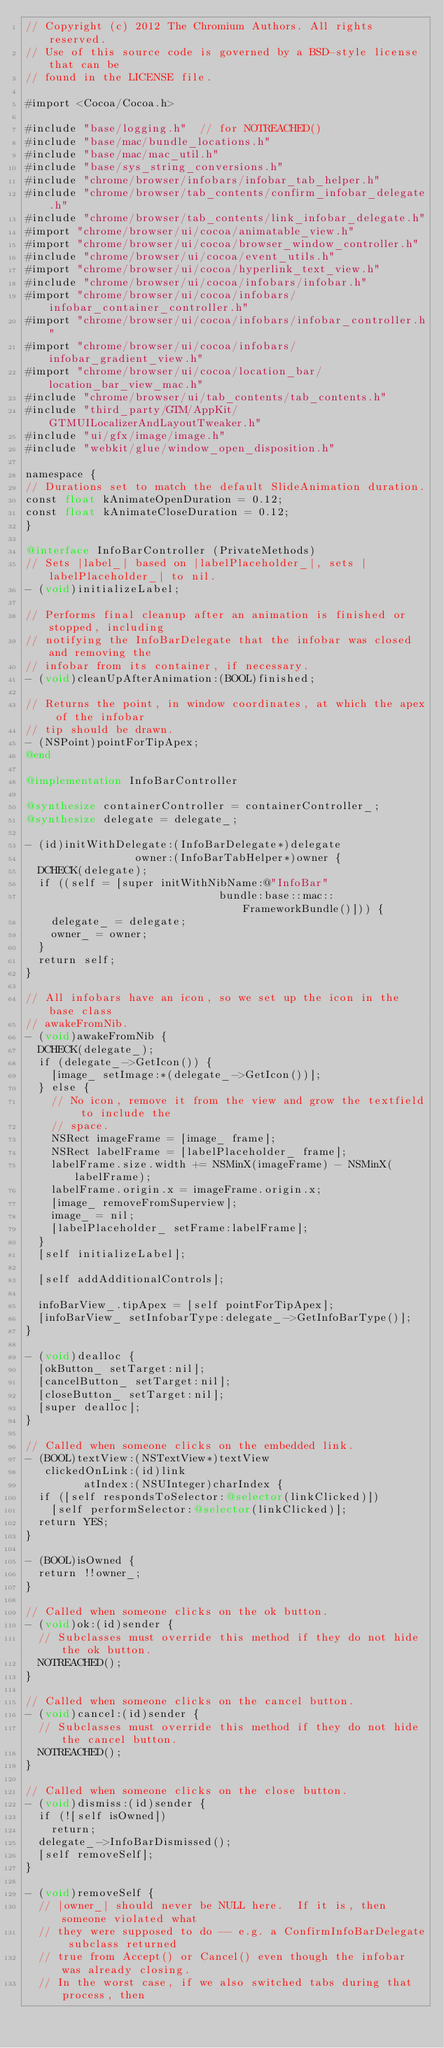<code> <loc_0><loc_0><loc_500><loc_500><_ObjectiveC_>// Copyright (c) 2012 The Chromium Authors. All rights reserved.
// Use of this source code is governed by a BSD-style license that can be
// found in the LICENSE file.

#import <Cocoa/Cocoa.h>

#include "base/logging.h"  // for NOTREACHED()
#include "base/mac/bundle_locations.h"
#include "base/mac/mac_util.h"
#include "base/sys_string_conversions.h"
#include "chrome/browser/infobars/infobar_tab_helper.h"
#include "chrome/browser/tab_contents/confirm_infobar_delegate.h"
#include "chrome/browser/tab_contents/link_infobar_delegate.h"
#import "chrome/browser/ui/cocoa/animatable_view.h"
#import "chrome/browser/ui/cocoa/browser_window_controller.h"
#include "chrome/browser/ui/cocoa/event_utils.h"
#import "chrome/browser/ui/cocoa/hyperlink_text_view.h"
#include "chrome/browser/ui/cocoa/infobars/infobar.h"
#import "chrome/browser/ui/cocoa/infobars/infobar_container_controller.h"
#import "chrome/browser/ui/cocoa/infobars/infobar_controller.h"
#import "chrome/browser/ui/cocoa/infobars/infobar_gradient_view.h"
#import "chrome/browser/ui/cocoa/location_bar/location_bar_view_mac.h"
#include "chrome/browser/ui/tab_contents/tab_contents.h"
#include "third_party/GTM/AppKit/GTMUILocalizerAndLayoutTweaker.h"
#include "ui/gfx/image/image.h"
#include "webkit/glue/window_open_disposition.h"

namespace {
// Durations set to match the default SlideAnimation duration.
const float kAnimateOpenDuration = 0.12;
const float kAnimateCloseDuration = 0.12;
}

@interface InfoBarController (PrivateMethods)
// Sets |label_| based on |labelPlaceholder_|, sets |labelPlaceholder_| to nil.
- (void)initializeLabel;

// Performs final cleanup after an animation is finished or stopped, including
// notifying the InfoBarDelegate that the infobar was closed and removing the
// infobar from its container, if necessary.
- (void)cleanUpAfterAnimation:(BOOL)finished;

// Returns the point, in window coordinates, at which the apex of the infobar
// tip should be drawn.
- (NSPoint)pointForTipApex;
@end

@implementation InfoBarController

@synthesize containerController = containerController_;
@synthesize delegate = delegate_;

- (id)initWithDelegate:(InfoBarDelegate*)delegate
                 owner:(InfoBarTabHelper*)owner {
  DCHECK(delegate);
  if ((self = [super initWithNibName:@"InfoBar"
                              bundle:base::mac::FrameworkBundle()])) {
    delegate_ = delegate;
    owner_ = owner;
  }
  return self;
}

// All infobars have an icon, so we set up the icon in the base class
// awakeFromNib.
- (void)awakeFromNib {
  DCHECK(delegate_);
  if (delegate_->GetIcon()) {
    [image_ setImage:*(delegate_->GetIcon())];
  } else {
    // No icon, remove it from the view and grow the textfield to include the
    // space.
    NSRect imageFrame = [image_ frame];
    NSRect labelFrame = [labelPlaceholder_ frame];
    labelFrame.size.width += NSMinX(imageFrame) - NSMinX(labelFrame);
    labelFrame.origin.x = imageFrame.origin.x;
    [image_ removeFromSuperview];
    image_ = nil;
    [labelPlaceholder_ setFrame:labelFrame];
  }
  [self initializeLabel];

  [self addAdditionalControls];

  infoBarView_.tipApex = [self pointForTipApex];
  [infoBarView_ setInfobarType:delegate_->GetInfoBarType()];
}

- (void)dealloc {
  [okButton_ setTarget:nil];
  [cancelButton_ setTarget:nil];
  [closeButton_ setTarget:nil];
  [super dealloc];
}

// Called when someone clicks on the embedded link.
- (BOOL)textView:(NSTextView*)textView
   clickedOnLink:(id)link
         atIndex:(NSUInteger)charIndex {
  if ([self respondsToSelector:@selector(linkClicked)])
    [self performSelector:@selector(linkClicked)];
  return YES;
}

- (BOOL)isOwned {
  return !!owner_;
}

// Called when someone clicks on the ok button.
- (void)ok:(id)sender {
  // Subclasses must override this method if they do not hide the ok button.
  NOTREACHED();
}

// Called when someone clicks on the cancel button.
- (void)cancel:(id)sender {
  // Subclasses must override this method if they do not hide the cancel button.
  NOTREACHED();
}

// Called when someone clicks on the close button.
- (void)dismiss:(id)sender {
  if (![self isOwned])
    return;
  delegate_->InfoBarDismissed();
  [self removeSelf];
}

- (void)removeSelf {
  // |owner_| should never be NULL here.  If it is, then someone violated what
  // they were supposed to do -- e.g. a ConfirmInfoBarDelegate subclass returned
  // true from Accept() or Cancel() even though the infobar was already closing.
  // In the worst case, if we also switched tabs during that process, then</code> 